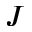Convert formula to latex. <formula><loc_0><loc_0><loc_500><loc_500>J</formula> 